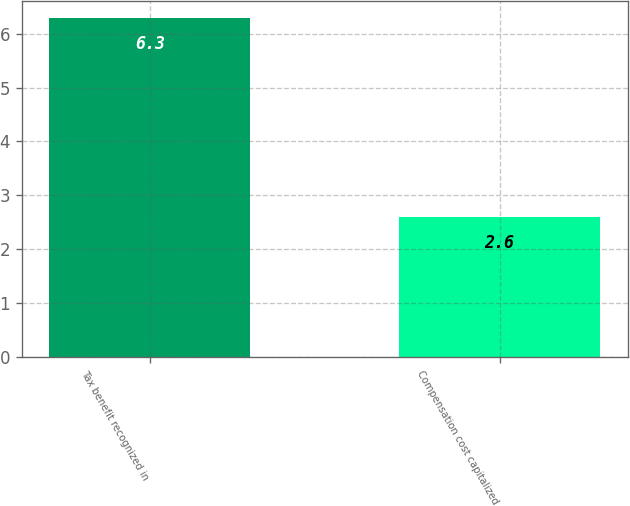Convert chart to OTSL. <chart><loc_0><loc_0><loc_500><loc_500><bar_chart><fcel>Tax benefit recognized in<fcel>Compensation cost capitalized<nl><fcel>6.3<fcel>2.6<nl></chart> 